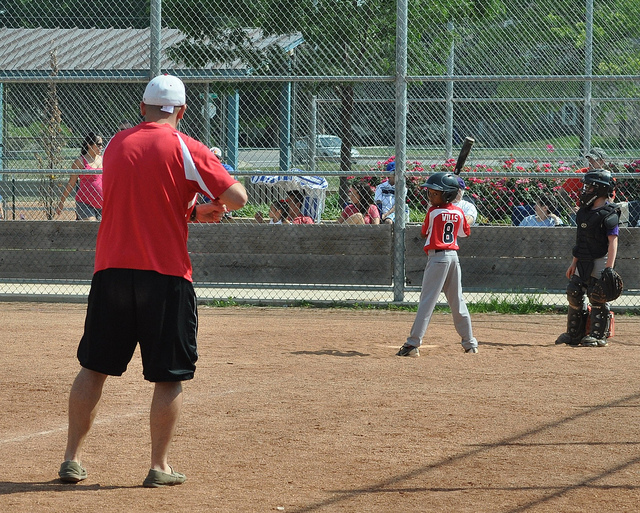Read all the text in this image. 8 